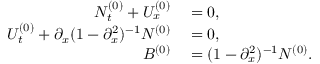<formula> <loc_0><loc_0><loc_500><loc_500>\begin{array} { r l } { N _ { t } ^ { ( 0 ) } + U _ { x } ^ { ( 0 ) } } & = 0 , } \\ { U _ { t } ^ { ( 0 ) } + \partial _ { x } ( 1 - \partial _ { x } ^ { 2 } ) ^ { - 1 } N ^ { ( 0 ) } } & = 0 , } \\ { B ^ { ( 0 ) } } & = ( 1 - \partial _ { x } ^ { 2 } ) ^ { - 1 } N ^ { ( 0 ) } . } \end{array}</formula> 